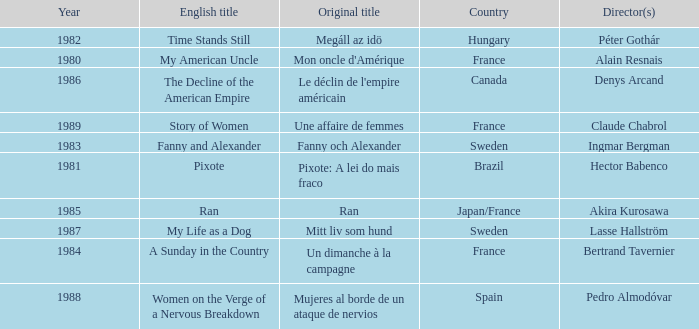What was the original title that was directed by Alain Resnais in France before 1986? Mon oncle d'Amérique. 